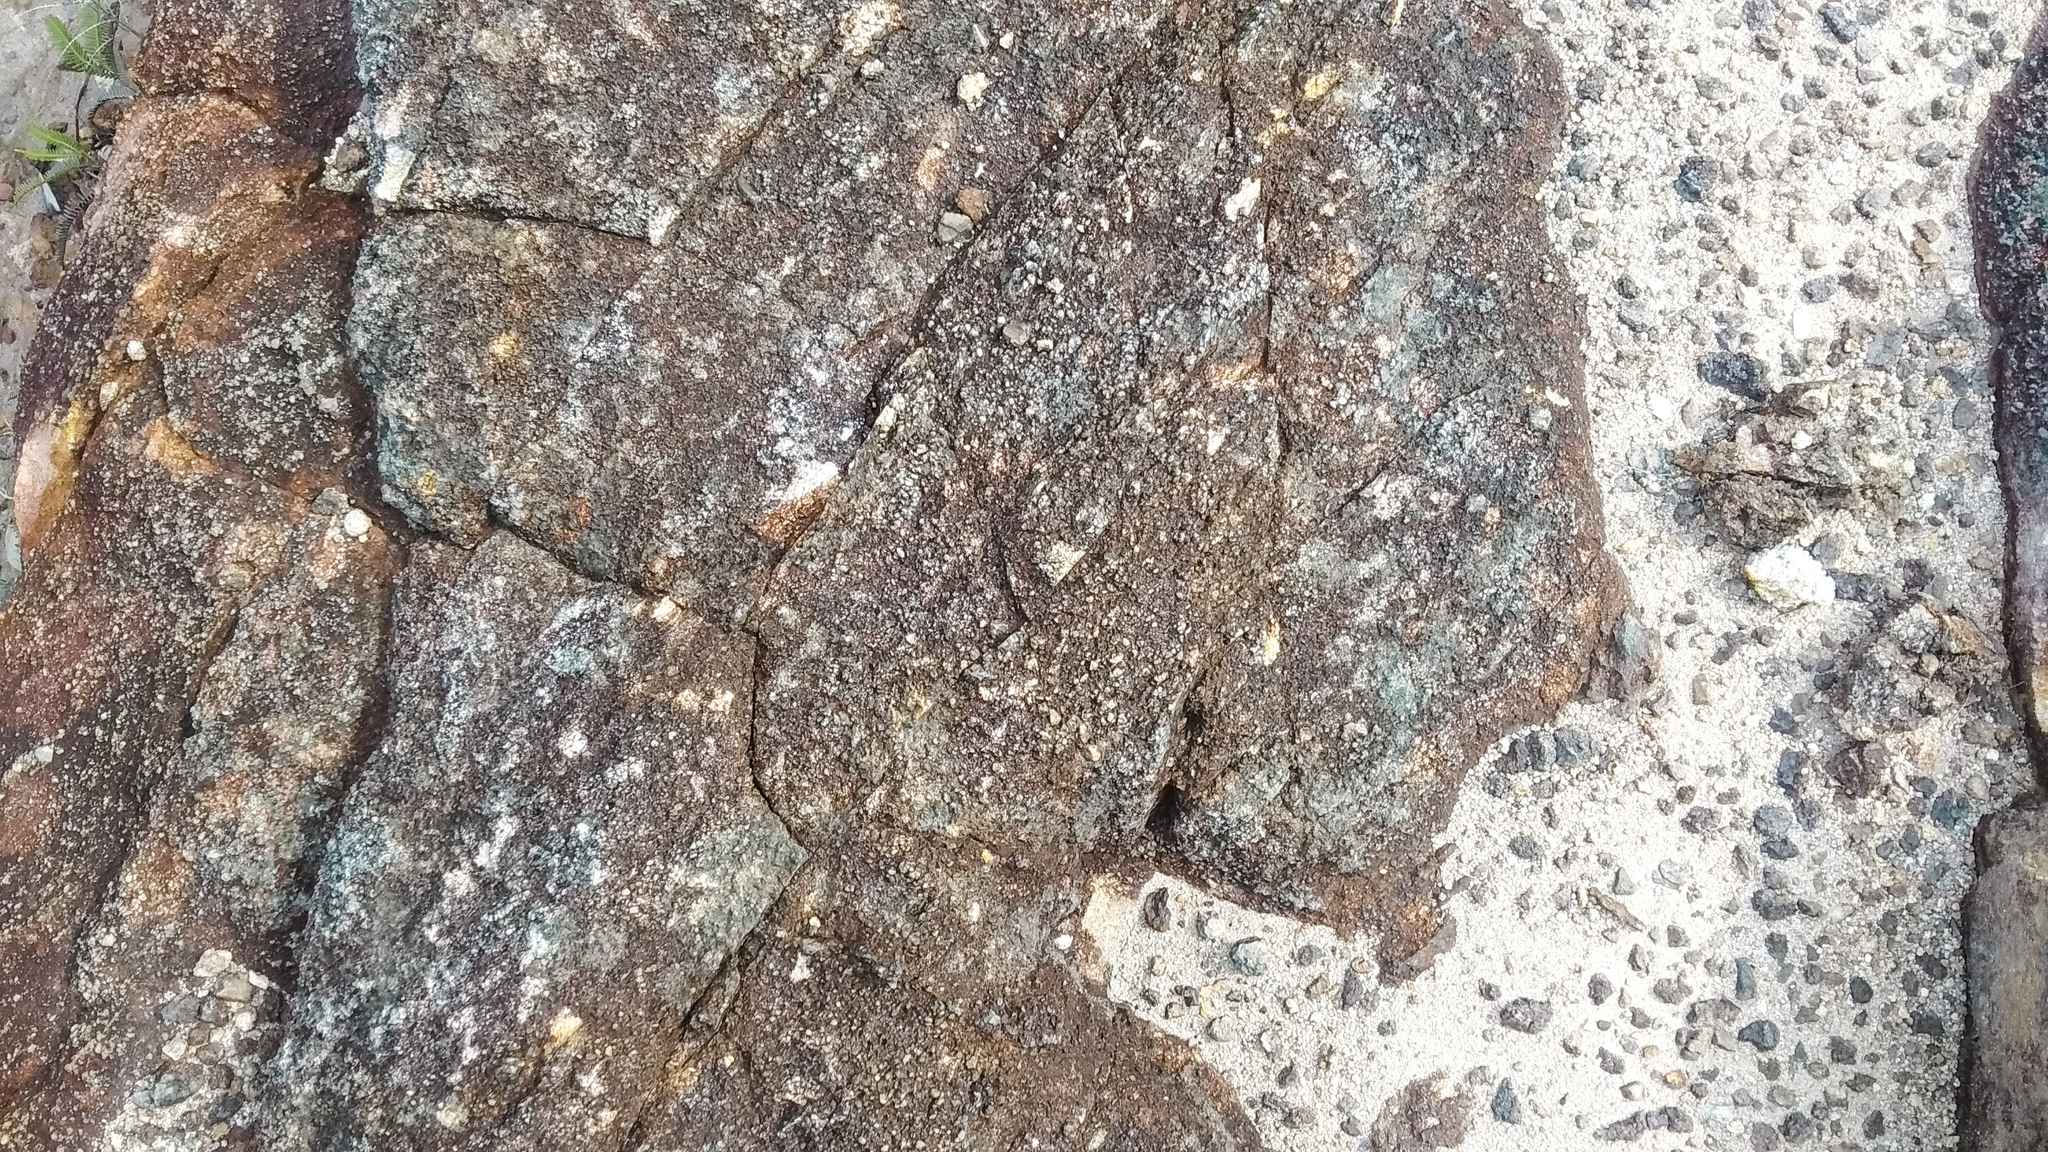What emotions does the image evoke? The image evokes a sense of resilience and timelessness. The weathered stones, with their rough textures and natural colors, suggest endurance and the passage of time. The small patches of moss and lichen add a touch of nature's quiet persistence, suggesting a delicate balance between strength and softness. Overall, the scene conveys a peaceful yet enduring character, invoking feelings of contemplation and respect for nature's resilience. Can you create a poem inspired by this image? Upon this ancient, weathered stone,
Time has carved, and moss has grown.
In hues of brown and gray it stands,
A testament to nature’s hands.

Through cracks and crevices, life finds a way,
In patches of green, where light meets day.
The stone, a canvas of earth's own art,
Holds stories of old within its heart.

Eroded by winds, kissed by rain,
Silent witness to joy and pain.
Enduring through the years gone by,
Underneath the open sky.

O rugged rock, so strong and true,
With a quiet grace and a timeless view.
You stand as both shield and home,
In your embrace, life has grown. 